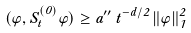<formula> <loc_0><loc_0><loc_500><loc_500>( \varphi , S ^ { ( 0 ) } _ { t } \varphi ) \geq a ^ { \prime \prime } \, t ^ { - d / 2 } \, \| \varphi \| _ { 1 } ^ { 2 }</formula> 